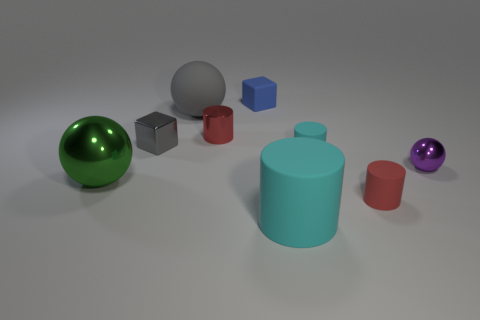Is there any other thing that is the same color as the big metallic object?
Your response must be concise. No. There is a metal object in front of the metal object that is on the right side of the small cyan thing; what is its size?
Offer a very short reply. Large. What color is the ball that is left of the tiny red rubber thing and behind the big green metallic thing?
Offer a terse response. Gray. How many other things are there of the same size as the gray metallic object?
Give a very brief answer. 5. Is the size of the gray metal block the same as the metallic ball that is to the right of the green metal ball?
Offer a very short reply. Yes. There is a shiny sphere that is the same size as the shiny block; what color is it?
Your answer should be very brief. Purple. The green shiny ball has what size?
Ensure brevity in your answer.  Large. Does the ball right of the small red metal object have the same material as the small gray object?
Your answer should be compact. Yes. Do the big shiny object and the big gray matte object have the same shape?
Your answer should be compact. Yes. What shape is the tiny red thing on the right side of the large matte thing in front of the metallic sphere that is left of the small red matte object?
Make the answer very short. Cylinder. 